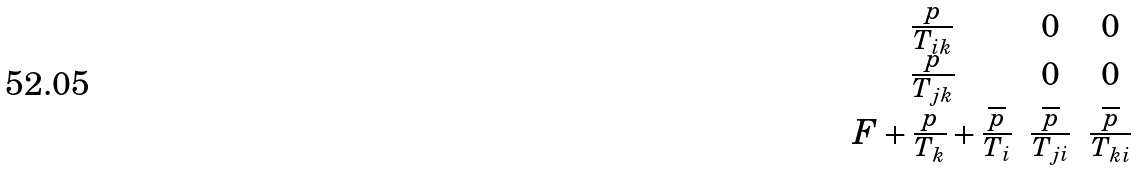<formula> <loc_0><loc_0><loc_500><loc_500>\begin{matrix} \frac { p } { T _ { i k } } & 0 & 0 \\ \frac { p } { T _ { j k } } & 0 & 0 \\ F + \frac { p } { T _ { k } } + \frac { \overline { p } } { T _ { i } } & \frac { \overline { p } } { T _ { j i } } & \frac { \overline { p } } { T _ { k i } } \end{matrix}</formula> 